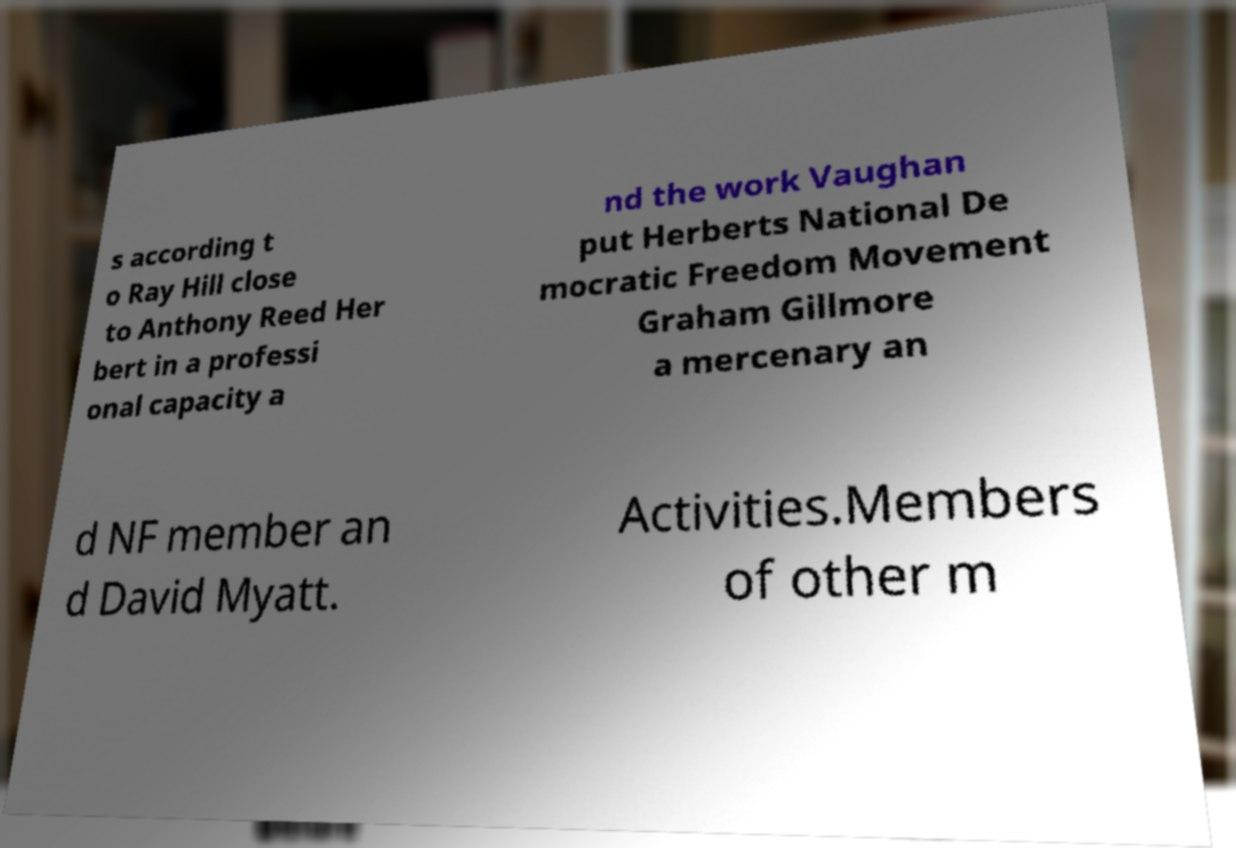Could you extract and type out the text from this image? s according t o Ray Hill close to Anthony Reed Her bert in a professi onal capacity a nd the work Vaughan put Herberts National De mocratic Freedom Movement Graham Gillmore a mercenary an d NF member an d David Myatt. Activities.Members of other m 